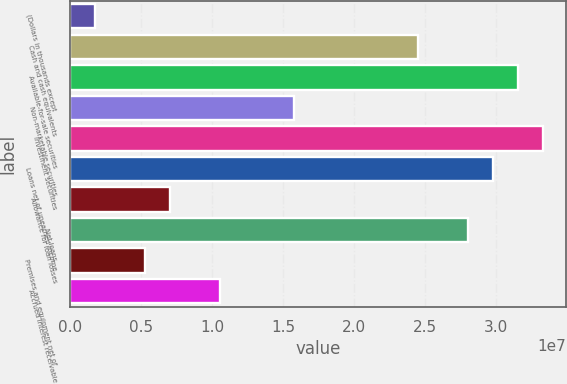Convert chart. <chart><loc_0><loc_0><loc_500><loc_500><bar_chart><fcel>(Dollars in thousands except<fcel>Cash and cash equivalents<fcel>Available-for-sale securities<fcel>Non-marketable securities<fcel>Investment securities<fcel>Loans net of unearned income<fcel>Allowance for loan losses<fcel>Net loans<fcel>Premises and equipment net of<fcel>Accrued interest receivable<nl><fcel>1.75281e+06<fcel>2.45388e+07<fcel>3.15499e+07<fcel>1.5775e+07<fcel>3.33027e+07<fcel>2.97972e+07<fcel>7.01113e+06<fcel>2.80444e+07<fcel>5.25836e+06<fcel>1.05167e+07<nl></chart> 